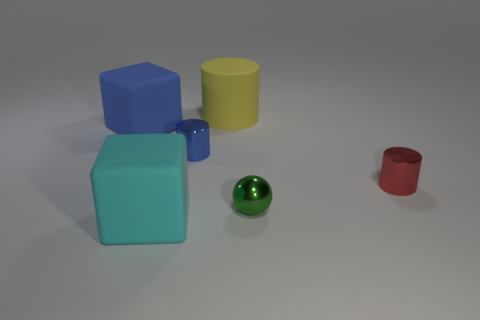Subtract all tiny cylinders. How many cylinders are left? 1 Subtract all blue cylinders. How many cylinders are left? 2 Add 2 yellow cylinders. How many objects exist? 8 Subtract all cubes. How many objects are left? 4 Subtract 1 blocks. How many blocks are left? 1 Add 6 cylinders. How many cylinders are left? 9 Add 1 large blue objects. How many large blue objects exist? 2 Subtract 0 purple cylinders. How many objects are left? 6 Subtract all gray blocks. Subtract all red spheres. How many blocks are left? 2 Subtract all cyan spheres. How many cyan blocks are left? 1 